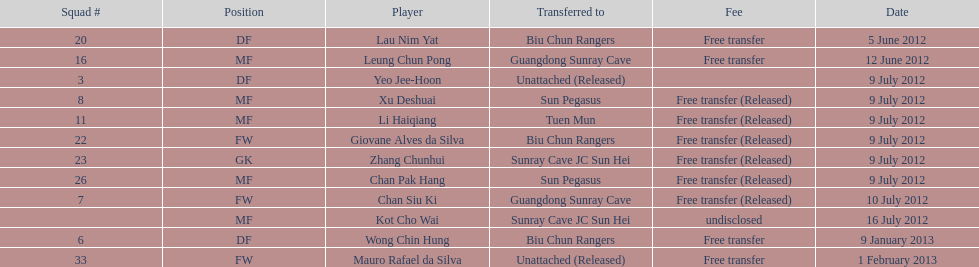To which team were lau nim yat and giovane alves de silva both transferred? Biu Chun Rangers. 